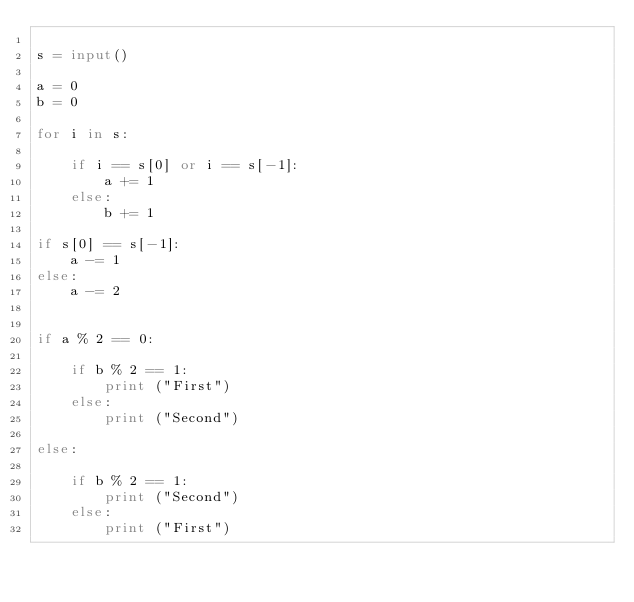Convert code to text. <code><loc_0><loc_0><loc_500><loc_500><_Python_>
s = input()

a = 0
b = 0

for i in s:

    if i == s[0] or i == s[-1]:
        a += 1
    else:
        b += 1

if s[0] == s[-1]:
    a -= 1
else:
    a -= 2


if a % 2 == 0:

    if b % 2 == 1:
        print ("First")
    else:
        print ("Second")

else:

    if b % 2 == 1:
        print ("Second")
    else:
        print ("First")
    
</code> 